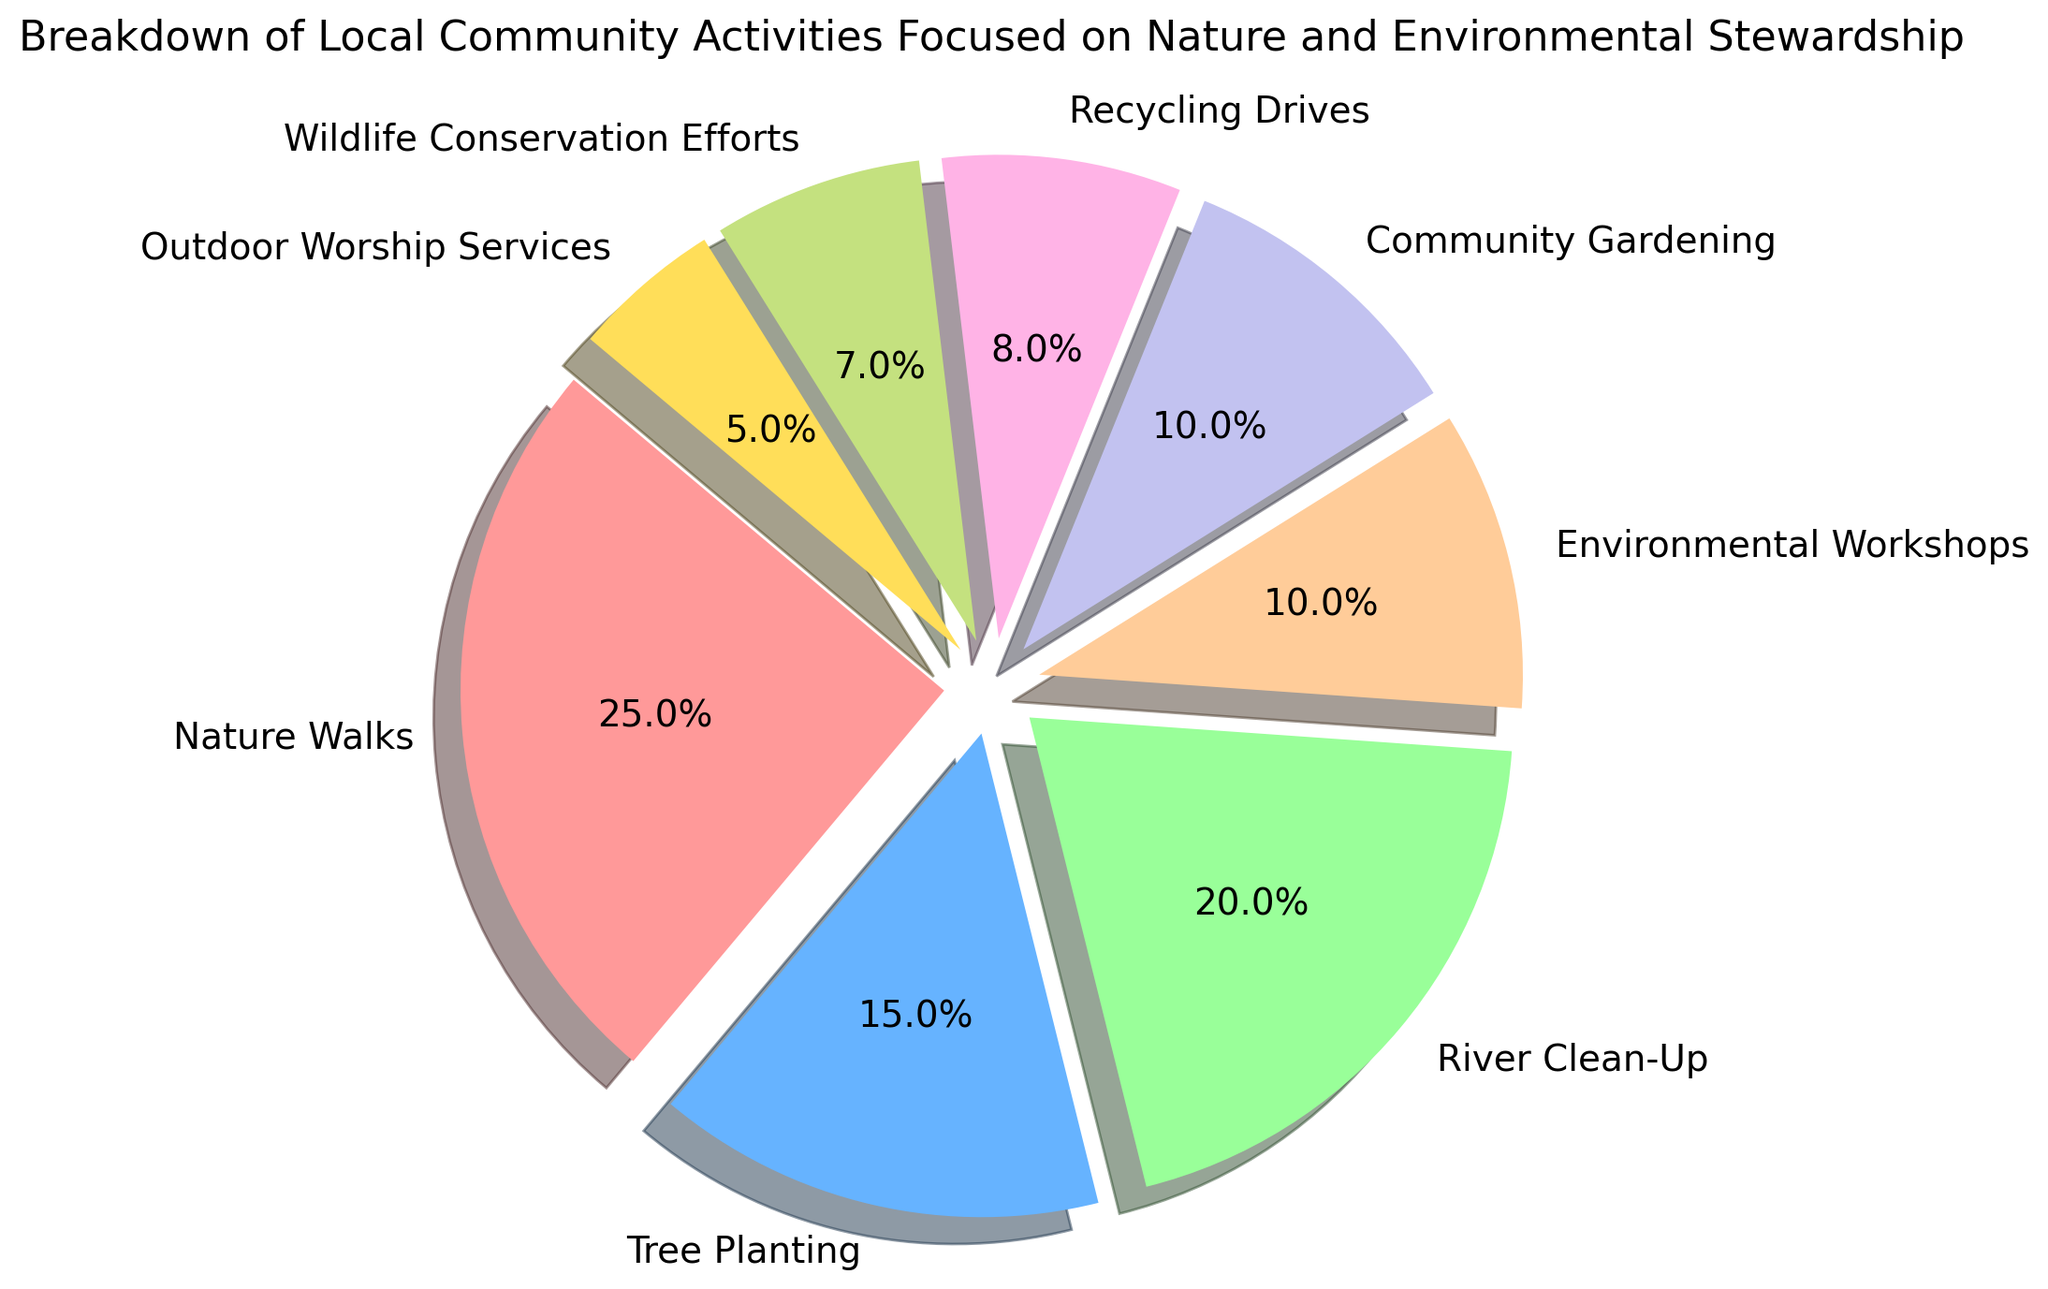What percentage of the activities are related to direct environmental cleanup (Tree Planting, River Clean-Up, Recycling Drives)? Sum the percentages for Tree Planting (15%), River Clean-Up (20%), and Recycling Drives (8%). 15 + 20 + 8 = 43
Answer: 43% Which activity has the smallest percentage share? Locate the activity with the smallest percentage value in the pie chart. Outdoor Worship Services has 5%, which is the smallest.
Answer: Outdoor Worship Services What is the total percentage of activities that involve plant care (Nature Walks, Tree Planting, Community Gardening)? Add the percentages for Nature Walks (25%), Tree Planting (15%), and Community Gardening (10%). 25 + 15 + 10 = 50
Answer: 50% Is the percentage of River Clean-Up activities greater than the combined percentage of Recycling Drives and Wildlife Conservation Efforts? Sum the percentages for Recycling Drives (8%) and Wildlife Conservation Efforts (7%); compare with River Clean-Up (20%). 8 + 7 = 15, and 20 > 15
Answer: Yes Which activity occupies the largest segment, and what is its percentage? Find the activity with the largest percentage value. Nature Walks has the largest at 25%.
Answer: Nature Walks, 25% How much more percentage is spent on Environmental Workshops compared to Outdoor Worship Services? Subtract the percentage of Outdoor Worship Services (5%) from Environmental Workshops (10%). 10 - 5 = 5
Answer: 5% What is the difference between the percentages for the top two activities? Which activities are they? Identify the top two activities (Nature Walks (25%) and River Clean-Up (20%)); subtract their percentages. 25 - 20 = 5
Answer: 5%, Nature Walks and River Clean-Up Which segment corresponds to green color when looking at the pie chart? Identify the segment that is colored green based on the legend colors. Community Gardening
Answer: Community Gardening 